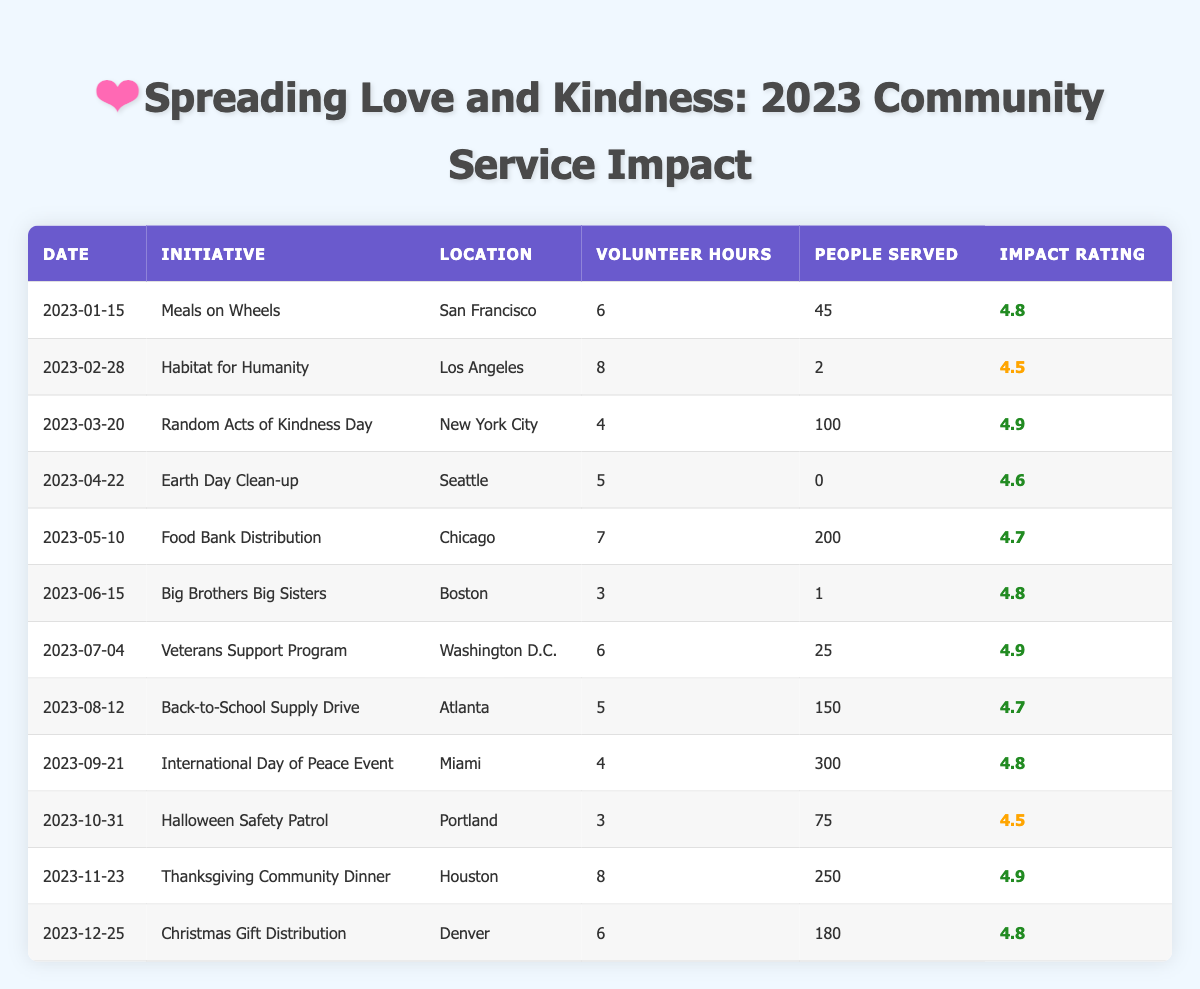What initiative had the highest impact rating? The highest impact rating in the table is 4.9. The initiatives with this rating are "Random Acts of Kindness Day," "Veterans Support Program," and "Thanksgiving Community Dinner." Since the question asks for the highest impact initiative, I can select any of these initiatives, but the most recent one in terms of data is "Thanksgiving Community Dinner."
Answer: Thanksgiving Community Dinner How many people were served by the Food Bank Distribution initiative? Referring to the table, the Food Bank Distribution initiative served 200 people.
Answer: 200 What was the total number of volunteer hours contributed across all initiatives listed? To calculate the total volunteer hours, I add up all the volunteer hours: 6 + 8 + 4 + 5 + 7 + 3 + 6 + 5 + 4 + 3 + 8 + 6 = 66 hours.
Answer: 66 Did the Earth Day Clean-up initiative serve any people? According to the table, the Earth Day Clean-up initiative had 0 people served. Hence, the answer is no.
Answer: No Which initiative had the lowest number of people served? Scanning the table, the "Habitat for Humanity" initiative served only 2 people, which is the lowest number among all initiatives listed.
Answer: Habitat for Humanity Is it true that all initiatives had an impact rating of at least 4.5? Checking the table, all impact ratings are at least 4.5. Therefore, the statement is correct.
Answer: Yes What is the average impact rating of all initiatives? To find the average impact rating, I sum the impact ratings: 4.8 + 4.5 + 4.9 + 4.6 + 4.7 + 4.8 + 4.9 + 4.7 + 4.8 + 4.5 + 4.9 + 4.8 = 57.2. Since there are 12 initiatives, the average is 57.2 / 12 = 4.77.
Answer: 4.77 Which initiative had the highest number of people served relative to its volunteer hours? For this, I need to find the ratio of people served to volunteer hours for each initiative. The "International Day of Peace Event" served 300 people with 4 hours, resulting in a ratio of 75 people per hour (300/4), which is the highest ratio in the table, comparing against the others.
Answer: International Day of Peace Event What initiative took place in the location of Boston? According to the table, "Big Brothers Big Sisters" took place in Boston.
Answer: Big Brothers Big Sisters 